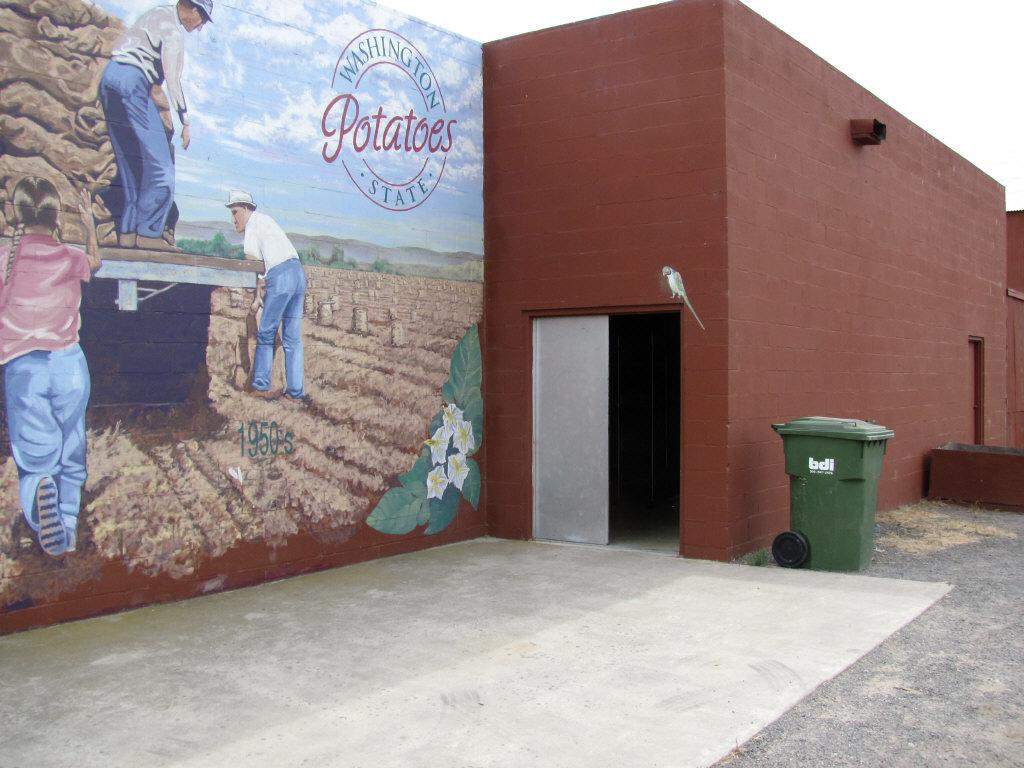<image>
Describe the image concisely. A mural about Washington state has an image of potato farmers. 